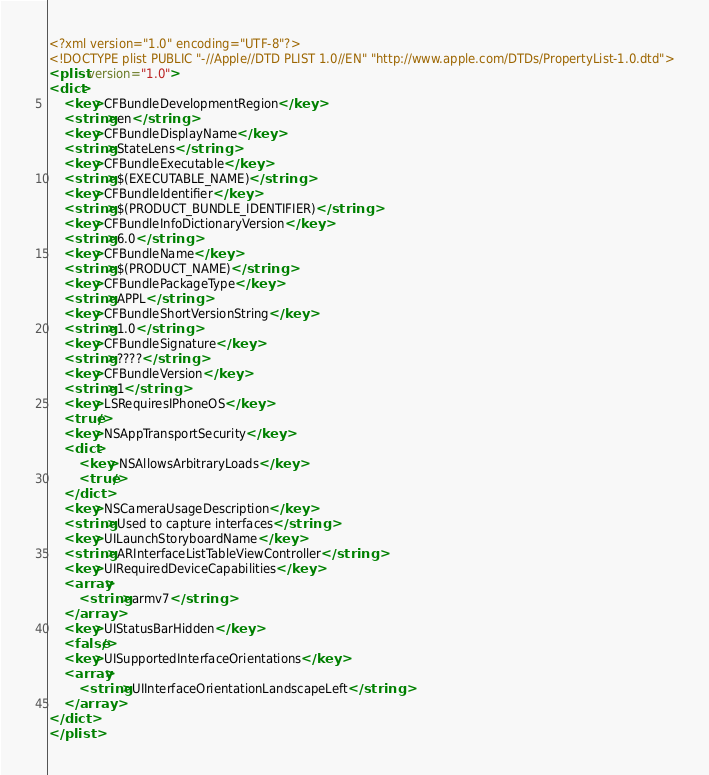<code> <loc_0><loc_0><loc_500><loc_500><_XML_><?xml version="1.0" encoding="UTF-8"?>
<!DOCTYPE plist PUBLIC "-//Apple//DTD PLIST 1.0//EN" "http://www.apple.com/DTDs/PropertyList-1.0.dtd">
<plist version="1.0">
<dict>
	<key>CFBundleDevelopmentRegion</key>
	<string>en</string>
	<key>CFBundleDisplayName</key>
	<string>StateLens</string>
	<key>CFBundleExecutable</key>
	<string>$(EXECUTABLE_NAME)</string>
	<key>CFBundleIdentifier</key>
	<string>$(PRODUCT_BUNDLE_IDENTIFIER)</string>
	<key>CFBundleInfoDictionaryVersion</key>
	<string>6.0</string>
	<key>CFBundleName</key>
	<string>$(PRODUCT_NAME)</string>
	<key>CFBundlePackageType</key>
	<string>APPL</string>
	<key>CFBundleShortVersionString</key>
	<string>1.0</string>
	<key>CFBundleSignature</key>
	<string>????</string>
	<key>CFBundleVersion</key>
	<string>1</string>
	<key>LSRequiresIPhoneOS</key>
	<true/>
	<key>NSAppTransportSecurity</key>
	<dict>
		<key>NSAllowsArbitraryLoads</key>
		<true/>
	</dict>
	<key>NSCameraUsageDescription</key>
	<string>Used to capture interfaces</string>
	<key>UILaunchStoryboardName</key>
	<string>ARInterfaceListTableViewController</string>
	<key>UIRequiredDeviceCapabilities</key>
	<array>
		<string>armv7</string>
	</array>
	<key>UIStatusBarHidden</key>
	<false/>
	<key>UISupportedInterfaceOrientations</key>
	<array>
		<string>UIInterfaceOrientationLandscapeLeft</string>
	</array>
</dict>
</plist>
</code> 